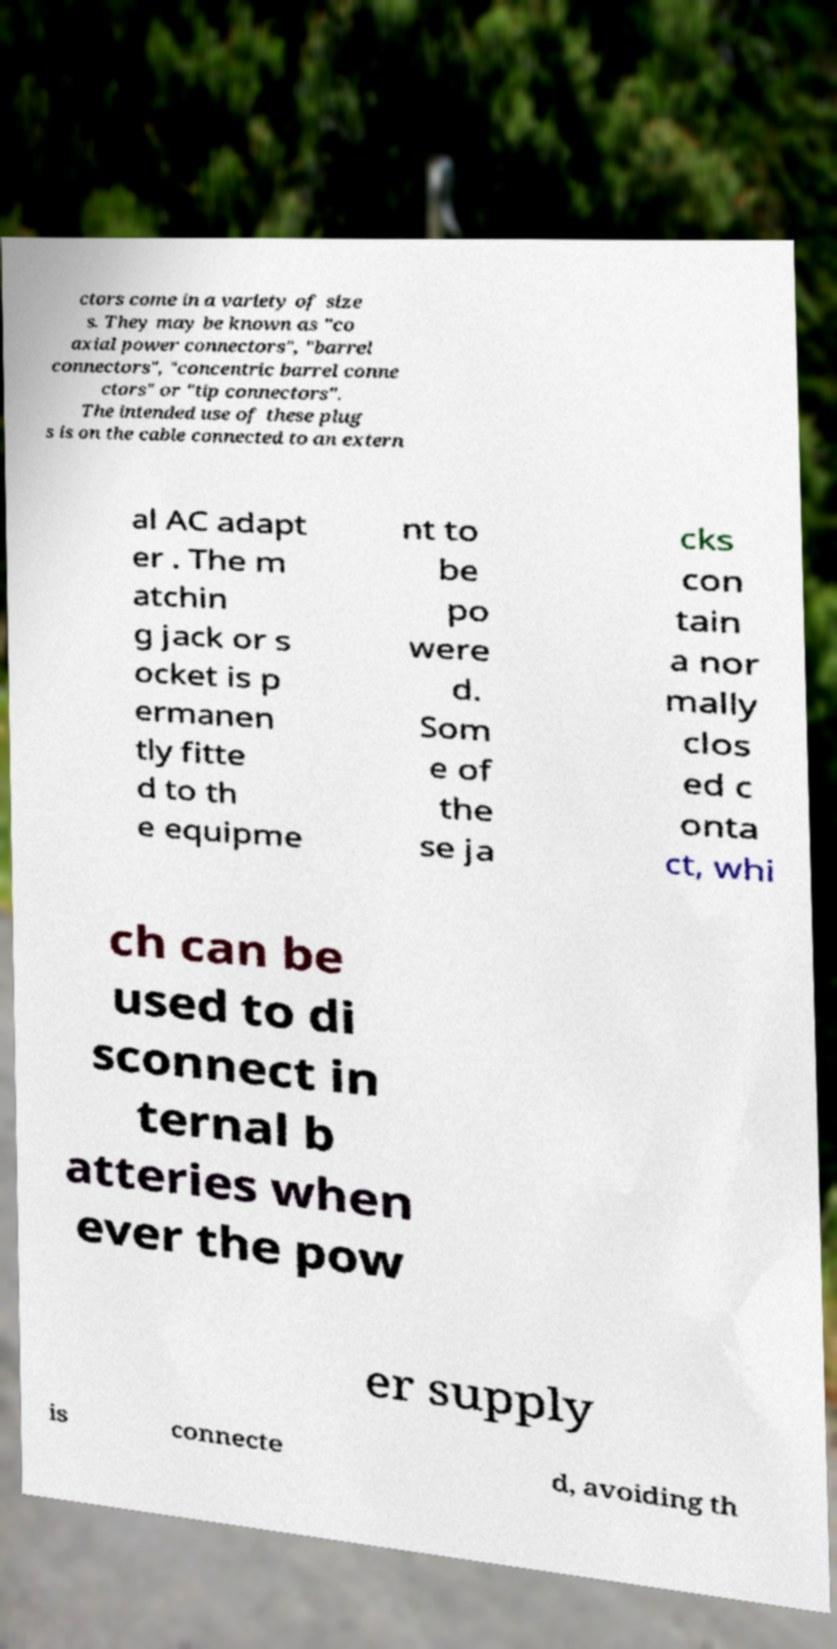What messages or text are displayed in this image? I need them in a readable, typed format. ctors come in a variety of size s. They may be known as "co axial power connectors", "barrel connectors", "concentric barrel conne ctors" or "tip connectors". The intended use of these plug s is on the cable connected to an extern al AC adapt er . The m atchin g jack or s ocket is p ermanen tly fitte d to th e equipme nt to be po were d. Som e of the se ja cks con tain a nor mally clos ed c onta ct, whi ch can be used to di sconnect in ternal b atteries when ever the pow er supply is connecte d, avoiding th 